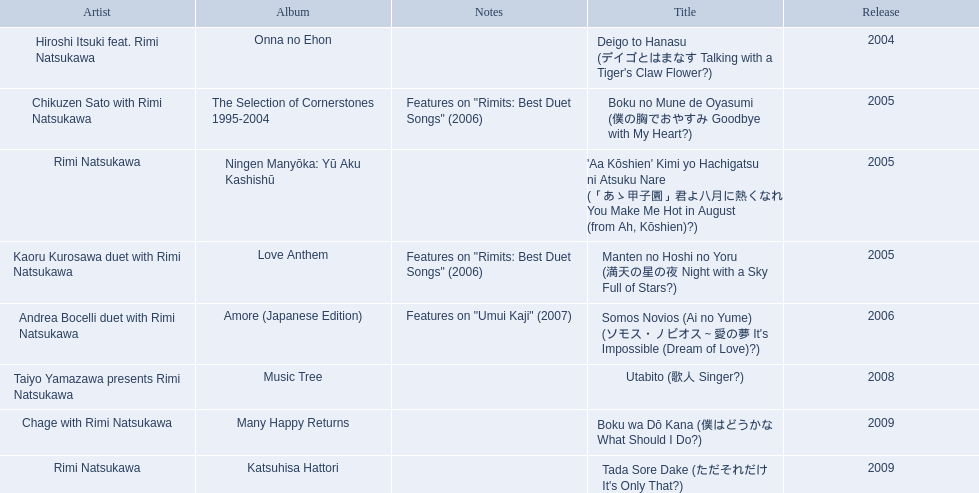What are the notes for sky full of stars? Features on "Rimits: Best Duet Songs" (2006). What other song features this same note? Boku no Mune de Oyasumi (僕の胸でおやすみ Goodbye with My Heart?). 